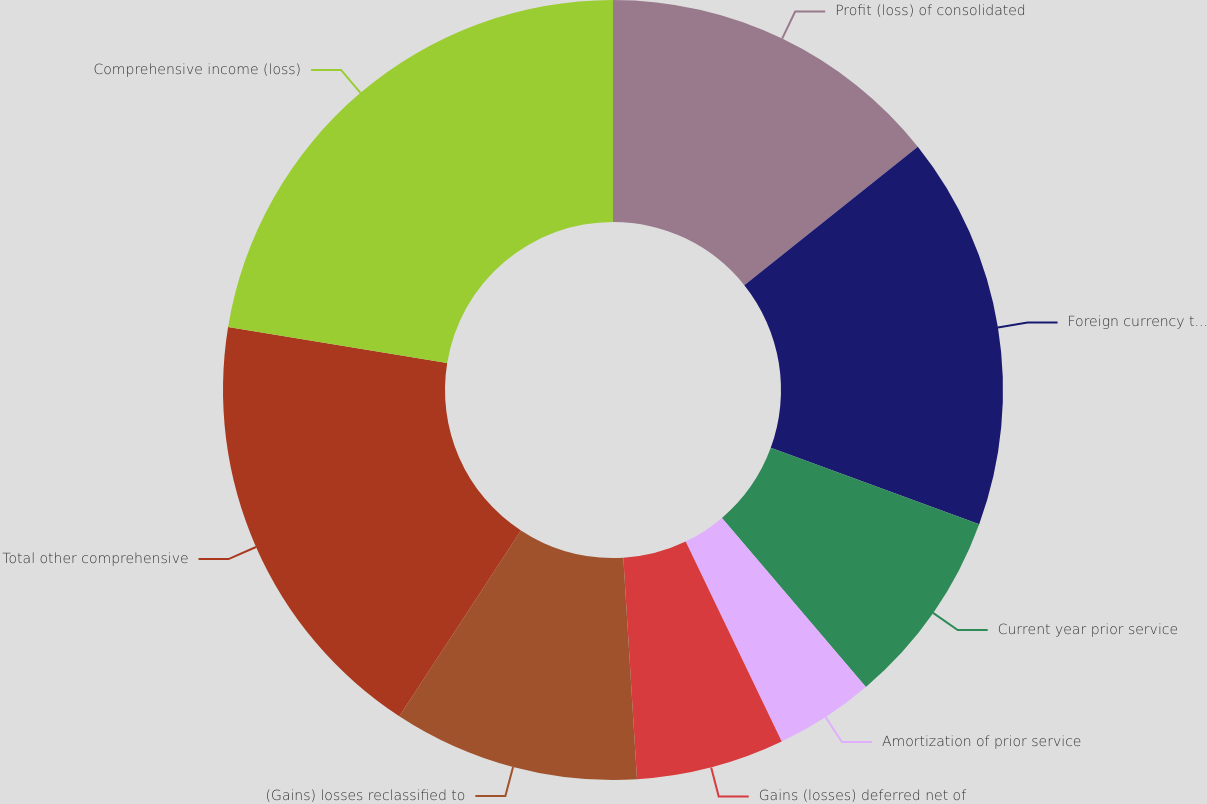Convert chart. <chart><loc_0><loc_0><loc_500><loc_500><pie_chart><fcel>Profit (loss) of consolidated<fcel>Foreign currency translation<fcel>Current year prior service<fcel>Amortization of prior service<fcel>Gains (losses) deferred net of<fcel>(Gains) losses reclassified to<fcel>Total other comprehensive<fcel>Comprehensive income (loss)<nl><fcel>14.28%<fcel>16.31%<fcel>8.18%<fcel>4.11%<fcel>6.14%<fcel>10.21%<fcel>18.35%<fcel>22.42%<nl></chart> 